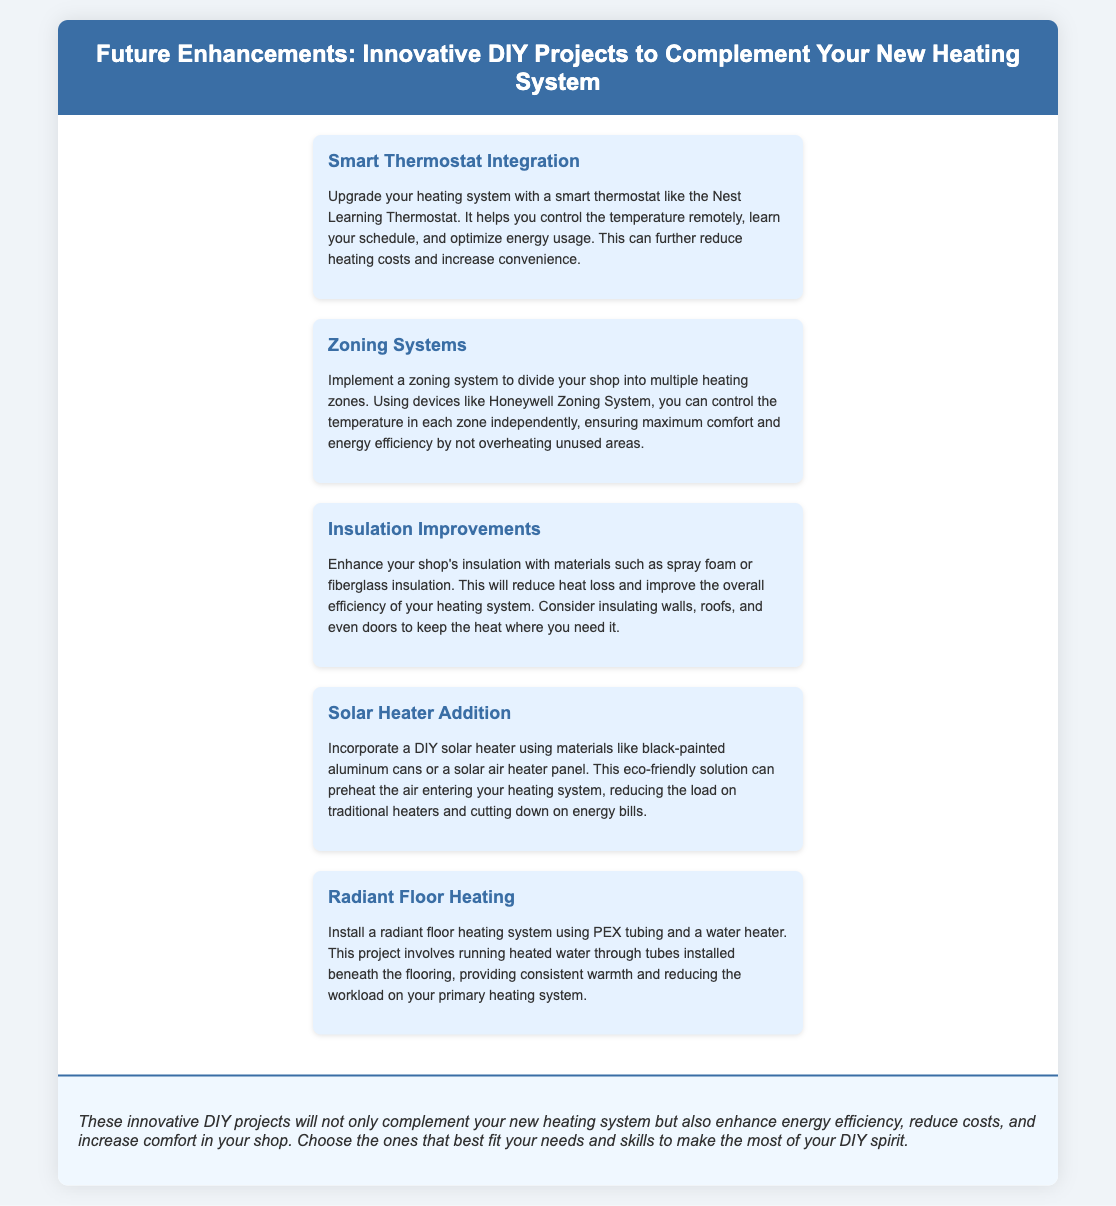What is the title of the presentation? The title is provided in the header section of the document, reflecting the main topic of the presentation.
Answer: Future Enhancements: Innovative DIY Projects to Complement Your New Heating System What type of thermostat is suggested for integration? The document specifically mentions the Nest Learning Thermostat as a recommended upgrade for the heating system.
Answer: Nest Learning Thermostat What is one advantage of implementing a zoning system? The text explains that a zoning system allows for controlling the temperature in each zone independently, which can increase energy efficiency.
Answer: Maximum comfort and energy efficiency What material is recommended for insulation improvements? The document lists materials such as spray foam or fiberglass insulation for enhancing the shop's insulation.
Answer: Spray foam or fiberglass insulation What is the DIY project that incorporates solar energy? The text refers to a DIY solar heater as a project that can be added to the heating system for eco-friendly benefits.
Answer: DIY solar heater How does radiant floor heating work? The document describes radiant floor heating as running heated water through tubes installed beneath the flooring.
Answer: Heated water through tubes Which section suggests reducing heat loss? Insulation Improvements is the section that discusses enhancing insulation to reduce heat loss.
Answer: Insulation Improvements What is the main goal of the proposed enhancements? The conclusion summarizes that the purpose of the enhancements is to complement the heating system while improving energy efficiency and comfort.
Answer: Enhance energy efficiency and comfort 